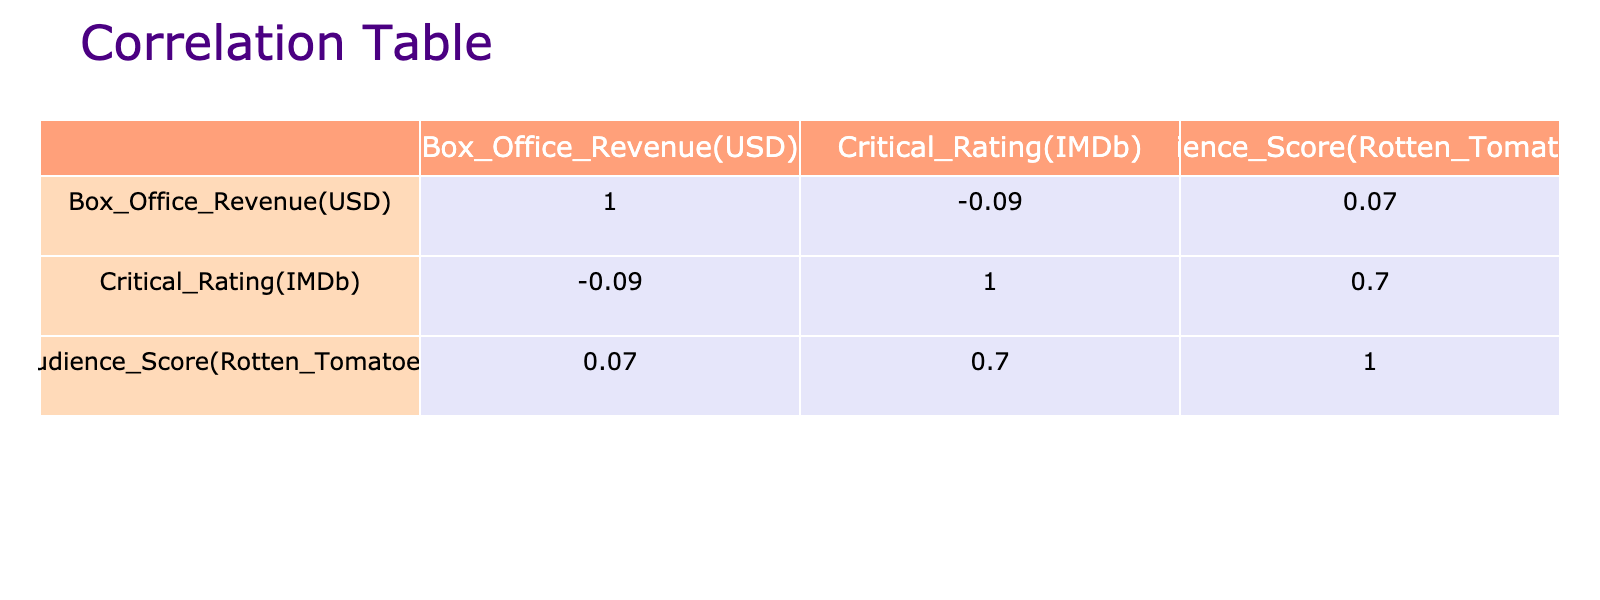What is the Box Office Revenue of "La La Land"? The table provides both the Box Office Revenue and the Film Title of "La La Land." According to the table, it states that the Box Office Revenue for "La La Land" is 446,000,000 USD.
Answer: 446000000 What is the Critical Rating of the film "The Vow"? The Critical Rating column tells us the rating for various films. Looking at "The Vow," it is listed as 6.8 on IMDb.
Answer: 6.8 Which film with a romantic genre has the highest Audience Score? The Audience Score column lists scores for all films. Scanning down, "La La Land" has the highest Audience Score at 91.
Answer: La La Land What is the average Box Office Revenue of all romantic dramas listed? The Box Office Revenue for Romantic Dramas can be summarized by adding up their revenues: 115,000,000 (The Notebook) + 100,000,000 (Pride and Prejudice) + 125,000,000 (The Vow) + 5,000,000 (Before Sunrise) + 47,000,000 (A Walk to Remember) + 207,000,000 (Me Before You) + 124,000,000 (The Fault in Our Stars) = 718,000,000 USD. There are 7 Romantic Dramas, so the average is 718,000,000 / 7 ≈ 102,571,429.
Answer: 102571429 Is "Bridget Jones's Diary" rated higher than 7.0 on IMDb? Checking the Critical Rating for "Bridget Jones's Diary," we find it is 6.7, which is less than 7.0. Therefore, the answer is no.
Answer: No Which film had a lower Audience Score: "The Fault in Our Stars" or "Silver Linings Playbook"? "The Fault in Our Stars" has an Audience Score of 86, while "Silver Linings Playbook" has a score of 92. Hence, "The Fault in Our Stars" is lower.
Answer: The Fault in Our Stars What is the difference in Box Office Revenue between "A Star is Born" and "500 Days of Summer"? First, we look up the Box Office Revenue: "A Star is Born" has 436,000,000 and "500 Days of Summer" has 60,000,000. The difference is 436,000,000 - 60,000,000 = 376,000,000.
Answer: 376000000 Which genre of film had a better average Critical Rating, Romantic Comedies or Romantic Dramas? Calculating the average for Romantic Comedies: (7.7 + 6.7 + 7.6) / 3 = 7.33. For Romantic Dramas: (7.8 + 7.8 + 6.8 + 8.1 + 7.4 + 7.4 + 7.7) / 7 = 7.57. Since 7.57 (Romantic Dramas) is higher than 7.33 (Romantic Comedies), Romantic Dramas had a better average.
Answer: Romantic Dramas How many films listed had Box Office Revenues over 200 million USD? The films that meet this criterion are "La La Land," "A Star is Born," "Bridget Jones's Diary," "Silver Linings Playbook," and "The Fault in Our Stars." Counting them gives a total of 5 films.
Answer: 5 